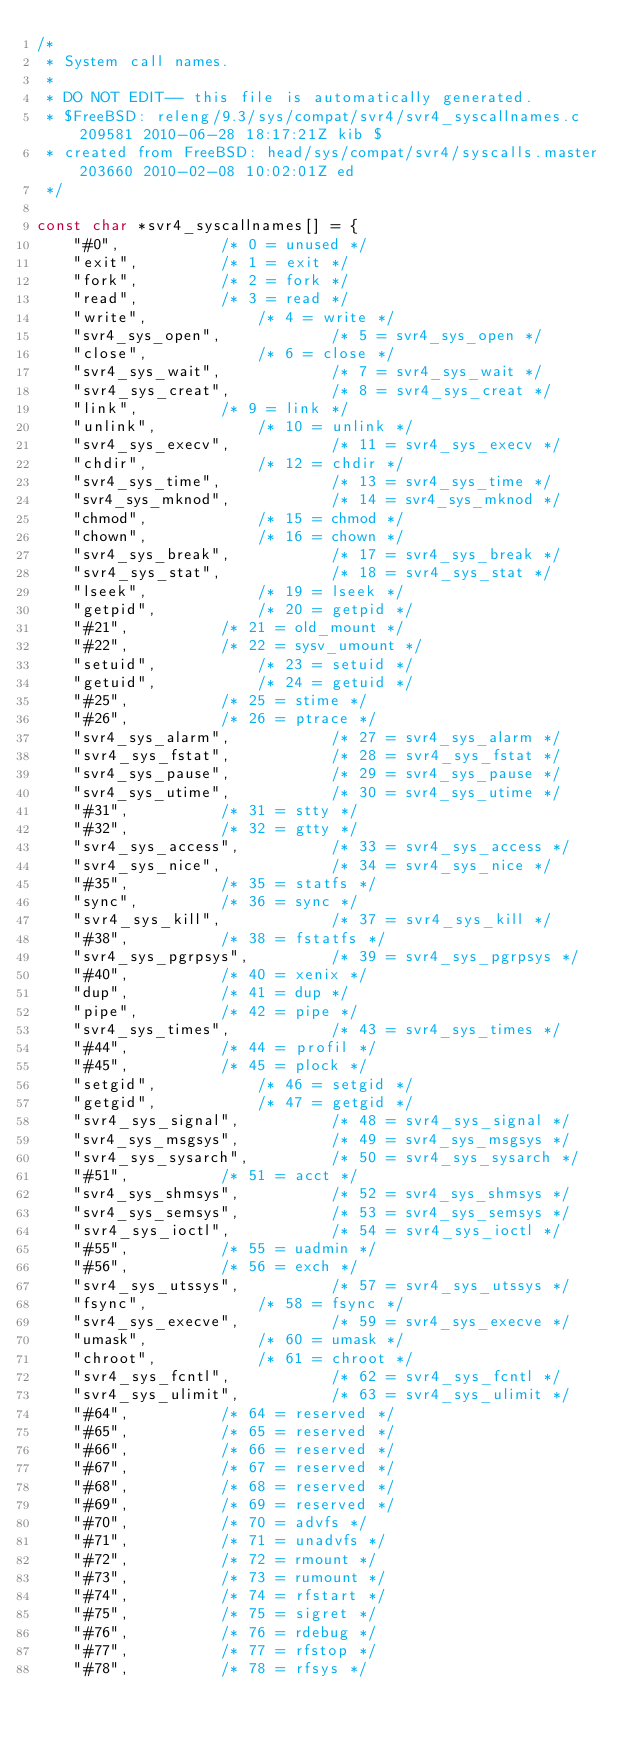Convert code to text. <code><loc_0><loc_0><loc_500><loc_500><_C_>/*
 * System call names.
 *
 * DO NOT EDIT-- this file is automatically generated.
 * $FreeBSD: releng/9.3/sys/compat/svr4/svr4_syscallnames.c 209581 2010-06-28 18:17:21Z kib $
 * created from FreeBSD: head/sys/compat/svr4/syscalls.master 203660 2010-02-08 10:02:01Z ed 
 */

const char *svr4_syscallnames[] = {
	"#0",			/* 0 = unused */
	"exit",			/* 1 = exit */
	"fork",			/* 2 = fork */
	"read",			/* 3 = read */
	"write",			/* 4 = write */
	"svr4_sys_open",			/* 5 = svr4_sys_open */
	"close",			/* 6 = close */
	"svr4_sys_wait",			/* 7 = svr4_sys_wait */
	"svr4_sys_creat",			/* 8 = svr4_sys_creat */
	"link",			/* 9 = link */
	"unlink",			/* 10 = unlink */
	"svr4_sys_execv",			/* 11 = svr4_sys_execv */
	"chdir",			/* 12 = chdir */
	"svr4_sys_time",			/* 13 = svr4_sys_time */
	"svr4_sys_mknod",			/* 14 = svr4_sys_mknod */
	"chmod",			/* 15 = chmod */
	"chown",			/* 16 = chown */
	"svr4_sys_break",			/* 17 = svr4_sys_break */
	"svr4_sys_stat",			/* 18 = svr4_sys_stat */
	"lseek",			/* 19 = lseek */
	"getpid",			/* 20 = getpid */
	"#21",			/* 21 = old_mount */
	"#22",			/* 22 = sysv_umount */
	"setuid",			/* 23 = setuid */
	"getuid",			/* 24 = getuid */
	"#25",			/* 25 = stime */
	"#26",			/* 26 = ptrace */
	"svr4_sys_alarm",			/* 27 = svr4_sys_alarm */
	"svr4_sys_fstat",			/* 28 = svr4_sys_fstat */
	"svr4_sys_pause",			/* 29 = svr4_sys_pause */
	"svr4_sys_utime",			/* 30 = svr4_sys_utime */
	"#31",			/* 31 = stty */
	"#32",			/* 32 = gtty */
	"svr4_sys_access",			/* 33 = svr4_sys_access */
	"svr4_sys_nice",			/* 34 = svr4_sys_nice */
	"#35",			/* 35 = statfs */
	"sync",			/* 36 = sync */
	"svr4_sys_kill",			/* 37 = svr4_sys_kill */
	"#38",			/* 38 = fstatfs */
	"svr4_sys_pgrpsys",			/* 39 = svr4_sys_pgrpsys */
	"#40",			/* 40 = xenix */
	"dup",			/* 41 = dup */
	"pipe",			/* 42 = pipe */
	"svr4_sys_times",			/* 43 = svr4_sys_times */
	"#44",			/* 44 = profil */
	"#45",			/* 45 = plock */
	"setgid",			/* 46 = setgid */
	"getgid",			/* 47 = getgid */
	"svr4_sys_signal",			/* 48 = svr4_sys_signal */
	"svr4_sys_msgsys",			/* 49 = svr4_sys_msgsys */
	"svr4_sys_sysarch",			/* 50 = svr4_sys_sysarch */
	"#51",			/* 51 = acct */
	"svr4_sys_shmsys",			/* 52 = svr4_sys_shmsys */
	"svr4_sys_semsys",			/* 53 = svr4_sys_semsys */
	"svr4_sys_ioctl",			/* 54 = svr4_sys_ioctl */
	"#55",			/* 55 = uadmin */
	"#56",			/* 56 = exch */
	"svr4_sys_utssys",			/* 57 = svr4_sys_utssys */
	"fsync",			/* 58 = fsync */
	"svr4_sys_execve",			/* 59 = svr4_sys_execve */
	"umask",			/* 60 = umask */
	"chroot",			/* 61 = chroot */
	"svr4_sys_fcntl",			/* 62 = svr4_sys_fcntl */
	"svr4_sys_ulimit",			/* 63 = svr4_sys_ulimit */
	"#64",			/* 64 = reserved */
	"#65",			/* 65 = reserved */
	"#66",			/* 66 = reserved */
	"#67",			/* 67 = reserved */
	"#68",			/* 68 = reserved */
	"#69",			/* 69 = reserved */
	"#70",			/* 70 = advfs */
	"#71",			/* 71 = unadvfs */
	"#72",			/* 72 = rmount */
	"#73",			/* 73 = rumount */
	"#74",			/* 74 = rfstart */
	"#75",			/* 75 = sigret */
	"#76",			/* 76 = rdebug */
	"#77",			/* 77 = rfstop */
	"#78",			/* 78 = rfsys */</code> 